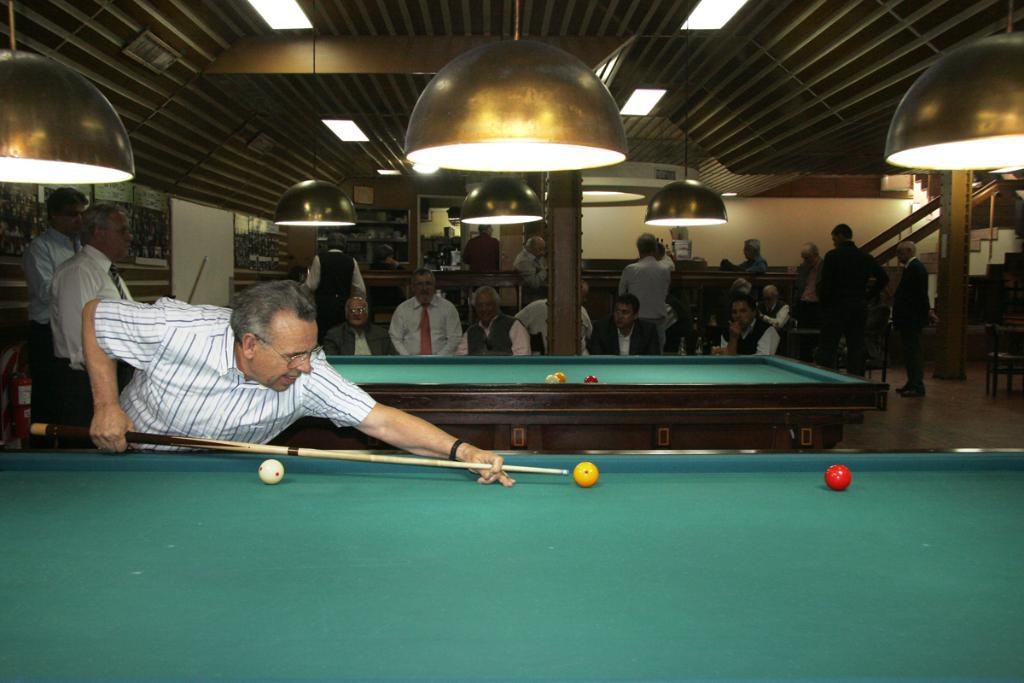What are the people in the image doing? There are people seated on chairs and standing in the image. What activity is being performed by one of the individuals? A man is hitting a ball with a Qeue on a pool board. What can be seen in the background or surrounding area of the image? There are lights visible in the image. Are there any architectural features present in the image? Yes, there are stairs in the image. What time of day is it in the image, considering the morning light? There is no mention of morning light in the image, so it cannot be determined from the image alone. 